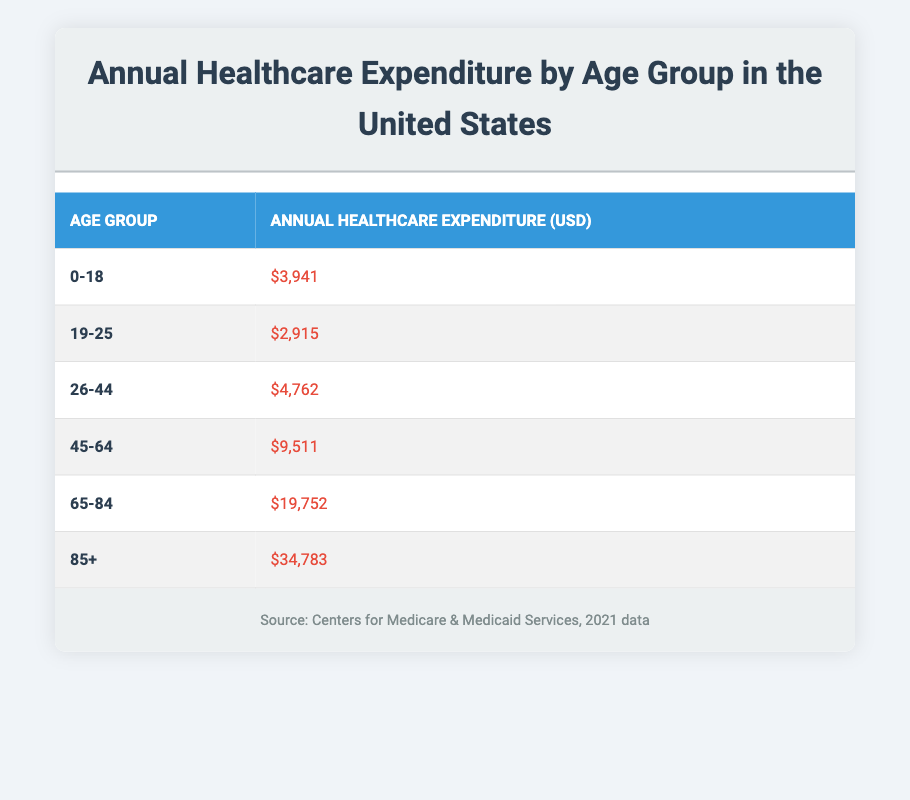What is the annual healthcare expenditure for the age group 0-18? The table lists the expenditure for the age group 0-18 as $3,941. Since it is a retrieval question, the answer can be directly found in the table.
Answer: $3,941 What is the highest annual healthcare expenditure among the age groups? The table shows that the age group 85+ has the highest expenditure at $34,783. This can be identified by comparing all values in the expenditure column.
Answer: $34,783 How much more does the age group 85+ spend on healthcare compared to the age group 19-25? The expenditure for 85+ is $34,783 and for 19-25 is $2,915. The difference is calculated as $34,783 - $2,915 = $31,868.
Answer: $31,868 What is the total annual healthcare expenditure for age groups 0-44 combined? To find the total, we sum the expenditures for the age groups 0-18 ($3,941), 19-25 ($2,915), and 26-44 ($4,762). The sum is $3,941 + $2,915 + $4,762 = $11,618.
Answer: $11,618 Is the annual healthcare expenditure for the age group 65-84 more than that for the age group 45-64? The expenditure for 65-84 is $19,752, while for 45-64 it is $9,511. Since $19,752 > $9,511, the answer is yes.
Answer: Yes What is the average annual healthcare expenditure across all age groups? To find the average, we first sum all the expenditures: $3,941 + $2,915 + $4,762 + $9,511 + $19,752 + $34,783 = $75,664. Then, we divide by the number of age groups (6): $75,664 / 6 = $12,610.67.
Answer: $12,610.67 Which age group spends the least on healthcare annually? The age group 19-25 has the lowest expenditure recorded at $2,915, which can be confirmed by comparing all expenditures in the table.
Answer: 19-25 If the healthcare expenditure for age group 45-64 were to increase by 10%, what would be the new expenditure? The current expenditure for 45-64 is $9,511. To find the new expenditure, we calculate 10% of $9,511, which is $9,511 * 0.10 = $951.10. Adding this to the original amount gives $9,511 + $951.10 = $10,462.10.
Answer: $10,462.10 